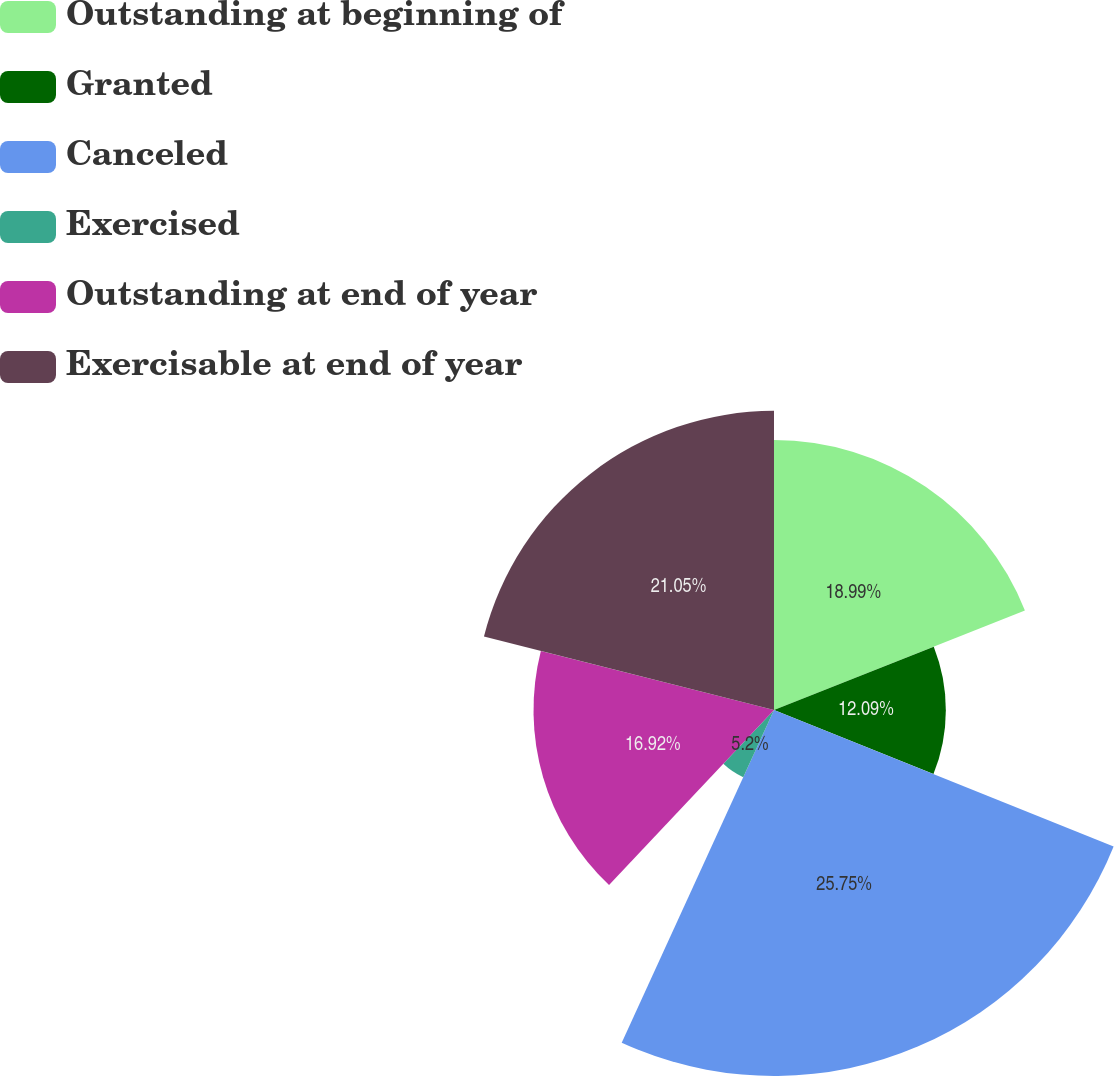<chart> <loc_0><loc_0><loc_500><loc_500><pie_chart><fcel>Outstanding at beginning of<fcel>Granted<fcel>Canceled<fcel>Exercised<fcel>Outstanding at end of year<fcel>Exercisable at end of year<nl><fcel>18.99%<fcel>12.09%<fcel>25.75%<fcel>5.2%<fcel>16.92%<fcel>21.05%<nl></chart> 